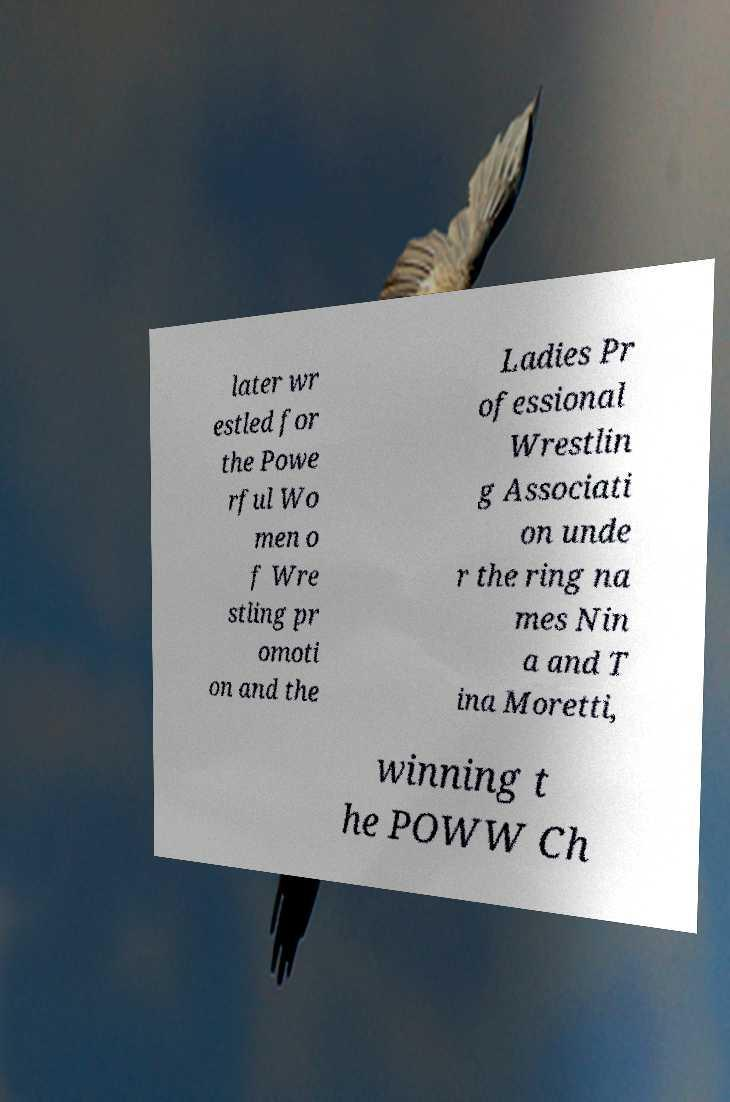Could you assist in decoding the text presented in this image and type it out clearly? later wr estled for the Powe rful Wo men o f Wre stling pr omoti on and the Ladies Pr ofessional Wrestlin g Associati on unde r the ring na mes Nin a and T ina Moretti, winning t he POWW Ch 